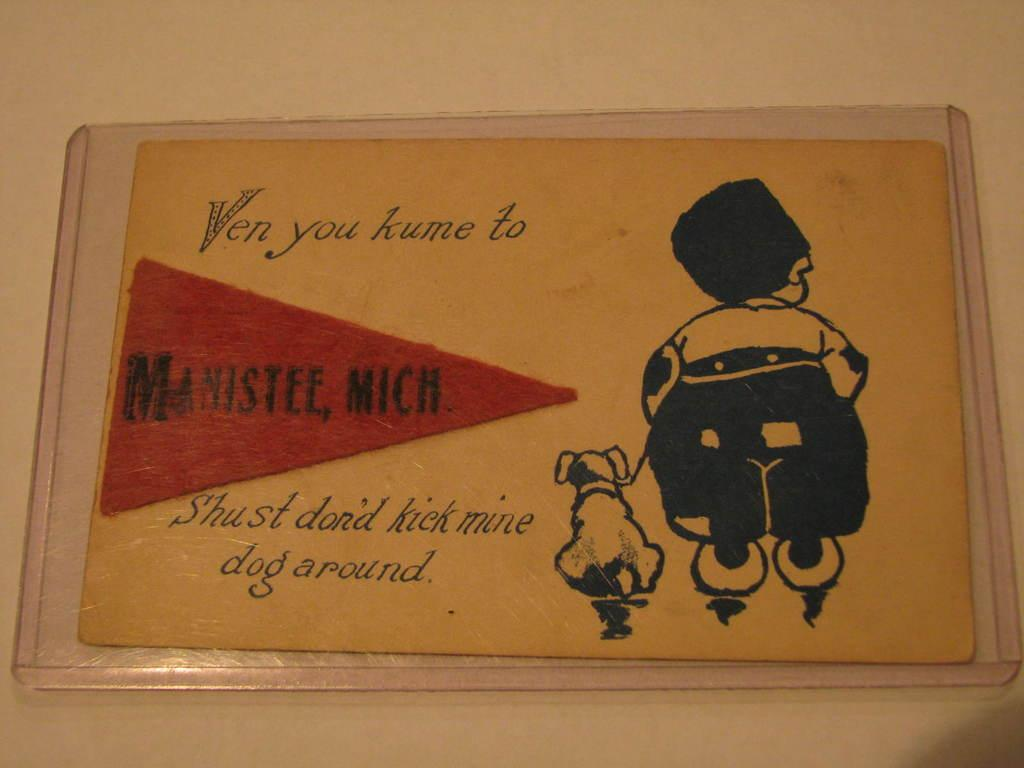What is the main object in the image? There is a board in the image. What is the board attached to? The board is attached to a cream-colored wall. What can be seen on the board? There is a painting of a person and a painting of an animal on the board. Is there any text on the board? Yes, there is writing on the board. Can you see a mountain in the background of the image? There is no mountain visible in the image; it only features a board with paintings and writing. 